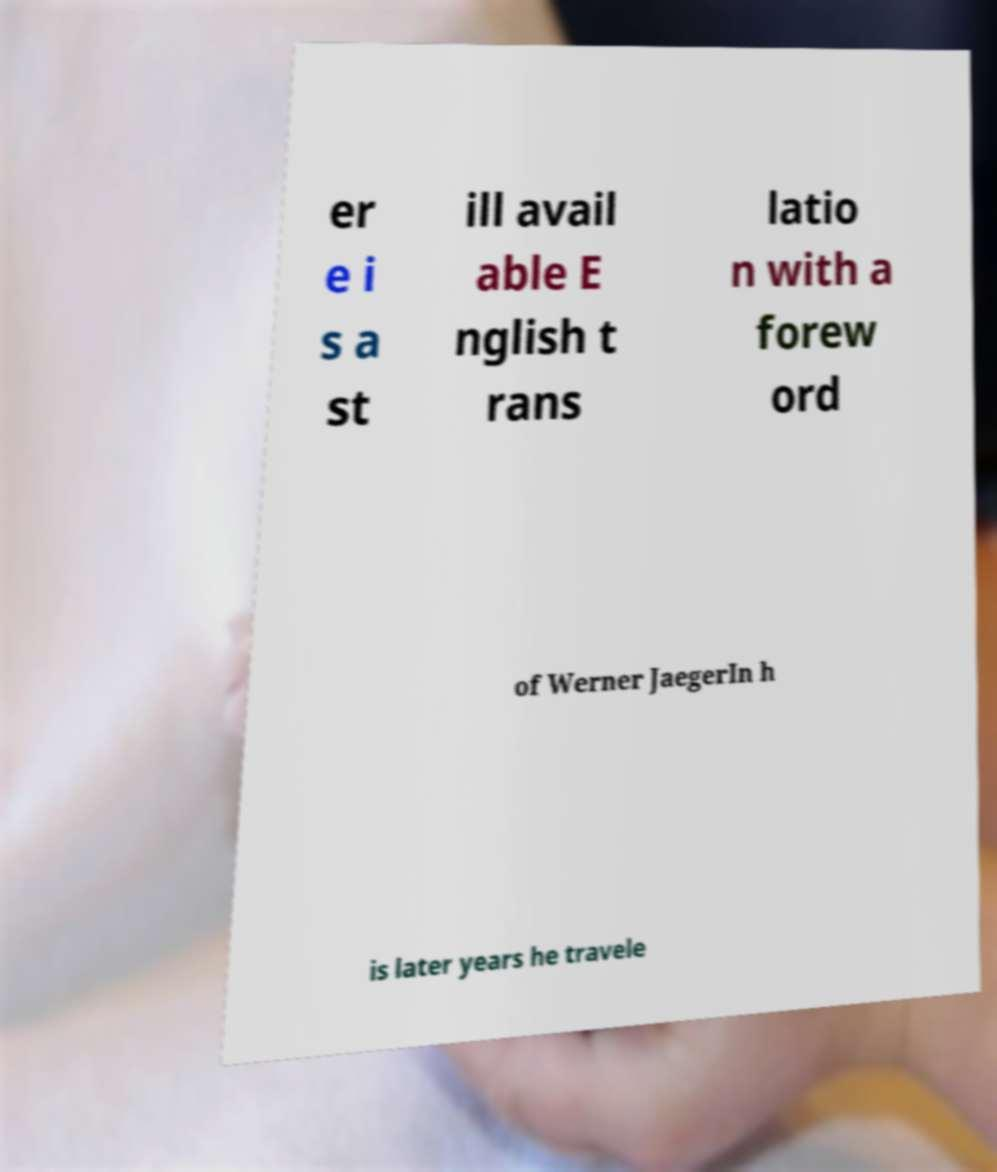I need the written content from this picture converted into text. Can you do that? er e i s a st ill avail able E nglish t rans latio n with a forew ord of Werner JaegerIn h is later years he travele 